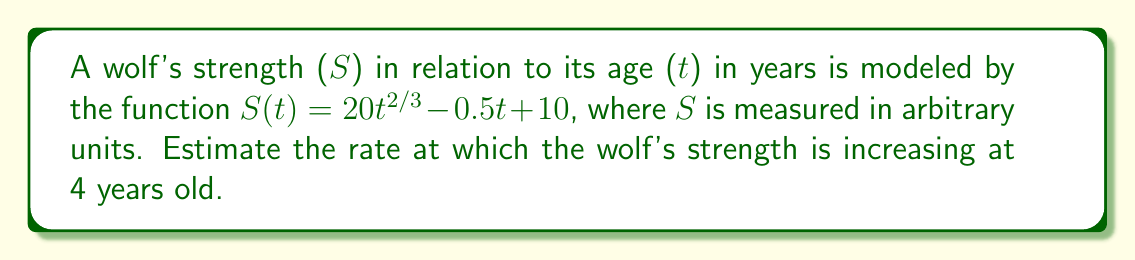Help me with this question. To estimate the rate at which the wolf's strength is increasing at a specific age, we need to find the derivative of the strength function and evaluate it at the given age.

1. Given function: $S(t) = 20t^{2/3} - 0.5t + 10$

2. Find the derivative $S'(t)$ using the power rule and constant rule:
   $$S'(t) = 20 \cdot \frac{2}{3} \cdot t^{-1/3} - 0.5$$

3. Simplify:
   $$S'(t) = \frac{40}{3t^{1/3}} - 0.5$$

4. Evaluate $S'(t)$ at $t = 4$:
   $$S'(4) = \frac{40}{3(4^{1/3})} - 0.5$$

5. Calculate:
   $$S'(4) = \frac{40}{3 \cdot 1.5874} - 0.5 \approx 7.94$$

The rate at which the wolf's strength is increasing at 4 years old is approximately 7.94 units per year.
Answer: $7.94$ units per year 